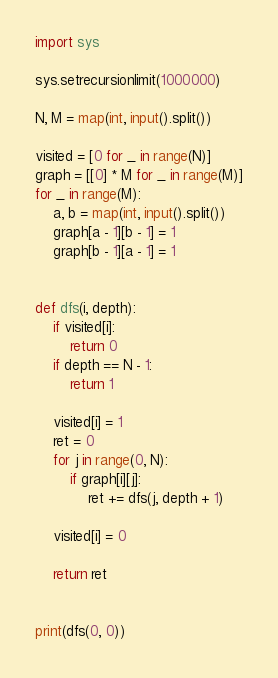<code> <loc_0><loc_0><loc_500><loc_500><_Python_>import sys

sys.setrecursionlimit(1000000)

N, M = map(int, input().split())

visited = [0 for _ in range(N)]
graph = [[0] * M for _ in range(M)]
for _ in range(M):
    a, b = map(int, input().split())
    graph[a - 1][b - 1] = 1
    graph[b - 1][a - 1] = 1


def dfs(i, depth):
    if visited[i]:
        return 0
    if depth == N - 1:
        return 1

    visited[i] = 1
    ret = 0
    for j in range(0, N):
        if graph[i][j]:
            ret += dfs(j, depth + 1)

    visited[i] = 0

    return ret


print(dfs(0, 0))
</code> 